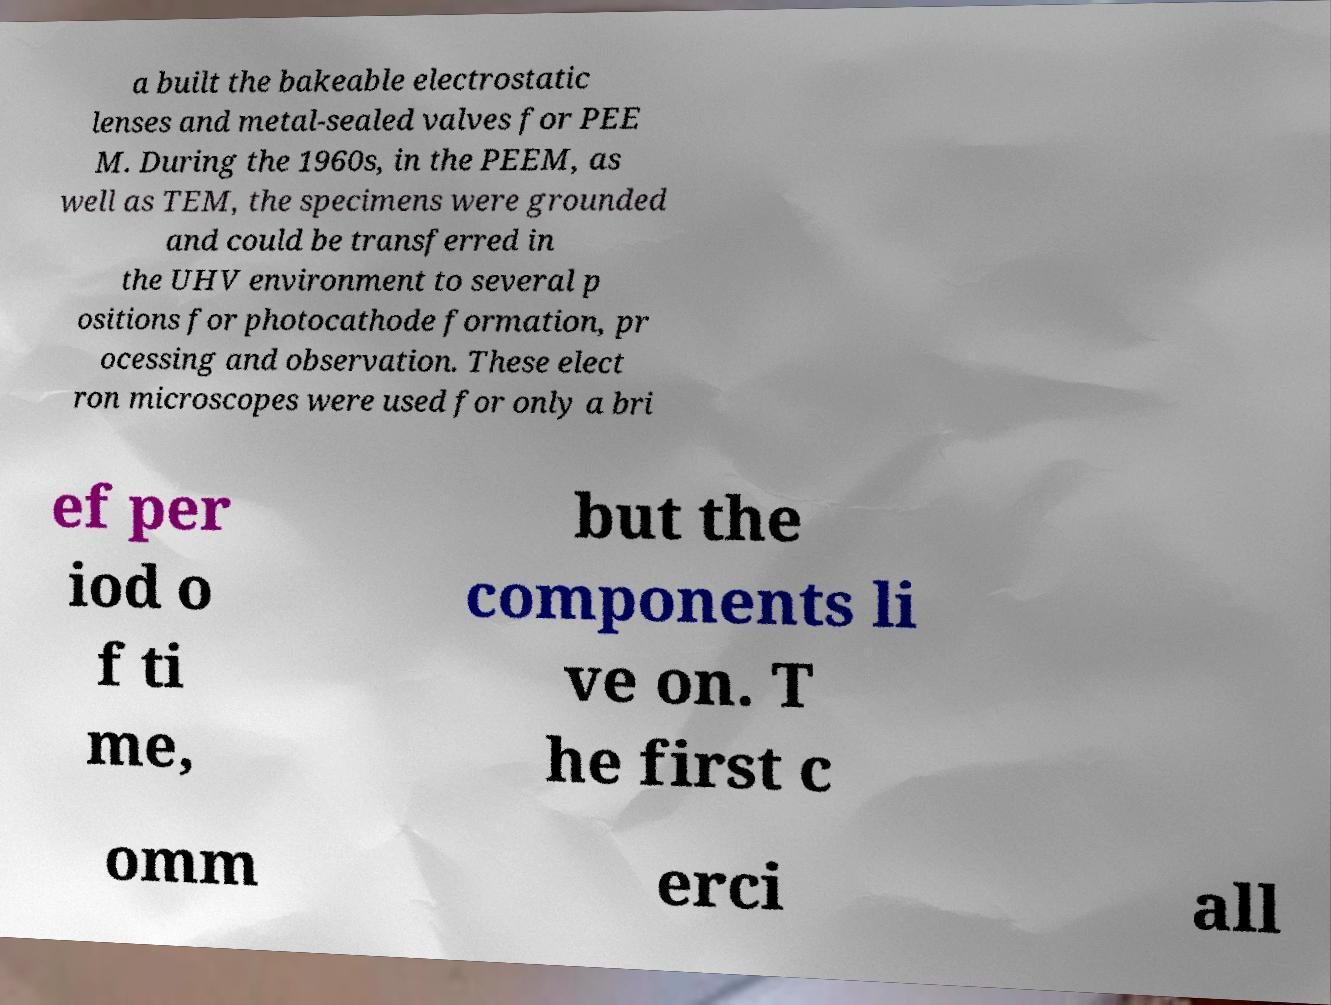Please read and relay the text visible in this image. What does it say? a built the bakeable electrostatic lenses and metal-sealed valves for PEE M. During the 1960s, in the PEEM, as well as TEM, the specimens were grounded and could be transferred in the UHV environment to several p ositions for photocathode formation, pr ocessing and observation. These elect ron microscopes were used for only a bri ef per iod o f ti me, but the components li ve on. T he first c omm erci all 